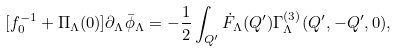<formula> <loc_0><loc_0><loc_500><loc_500>[ f _ { 0 } ^ { - 1 } + \Pi _ { \Lambda } ( 0 ) ] \partial _ { \Lambda } \bar { \phi } _ { \Lambda } = - \frac { 1 } { 2 } \int _ { Q ^ { \prime } } \dot { F } _ { \Lambda } ( { Q } ^ { \prime } ) \Gamma ^ { ( 3 ) } _ { \Lambda } ( { Q } ^ { \prime } , - { Q } ^ { \prime } , 0 ) ,</formula> 